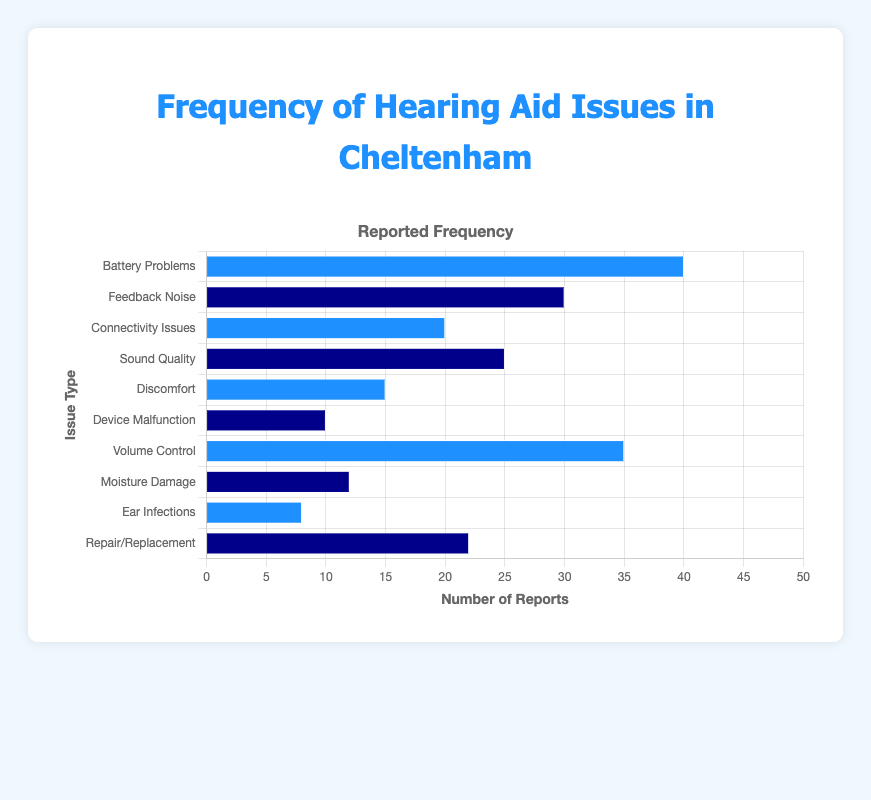What is the most frequently reported hearing aid issue? The most frequently reported hearing aid issue can be identified by observing the bar with the greatest height. Here, "Battery Problems" has the highest bar at 40 reports.
Answer: Battery Problems Which issue type has the least frequency reported? To find the least frequently reported issue, look for the shortest bar on the chart. "Ear Infections" has the shortest bar with 8 reports.
Answer: Ear Infections What is the combined reported frequency of Connectivity Issues and Discomfort? Summing the reported frequencies of "Connectivity Issues" (20) and "Discomfort" (15) gives 20 + 15 = 35.
Answer: 35 Is the reported frequency of Volume Control issues greater than that of Feedback Noise? Comparing the heights of the bars for "Volume Control" (35) and "Feedback Noise" (30) confirms that Volume Control has a higher frequency.
Answer: Yes How many more reports does Battery Problems have compared to Device Malfunction? The difference can be calculated by subtracting the reported frequency of "Device Malfunction" (10) from that of "Battery Problems" (40), which is 40 - 10 = 30.
Answer: 30 What is the total number of reports for all issues combined? Adding the frequencies for all issues: 40 + 30 + 20 + 25 + 15 + 10 + 35 + 12 + 8 + 22 results in 217.
Answer: 217 Which issues have more than 25 reported frequencies? By observing the chart, “Battery Problems” (40) and “Volume Control” (35) have more than 25 reports.
Answer: Battery Problems, Volume Control What is the average reported frequency of all issues? Calculate the sum of all reported frequencies, then divide by the number of issues: (40 + 30 + 20 + 25 + 15 + 10 + 35 + 12 + 8 + 22) / 10 = 217 / 10 = 21.7.
Answer: 21.7 Are there an equal number of issues reported by color? Count the number of blue and dark blue bars. Blue issues (5): Battery Problems, Connectivity Issues, Discomfort, Volume Control, Ear Infections. Dark blue issues (5): Feedback Noise, Sound Quality, Device Malfunction, Moisture Damage, Repair/Replacement.
Answer: Yes What is the difference in reported frequency between the tallest and shortest bars? Subtract the frequency of the shortest bar ("Ear Infections" at 8) from the tallest bar ("Battery Problems" at 40). So, the difference is 40 - 8 = 32.
Answer: 32 